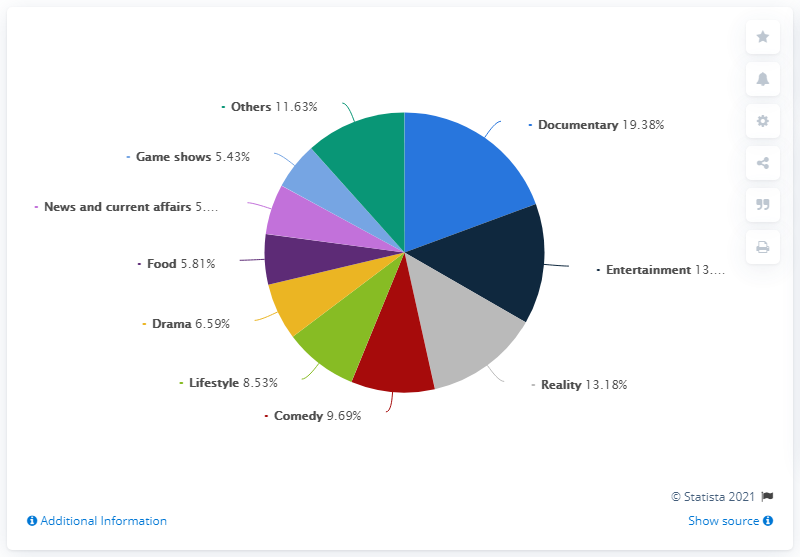How does the 'Entertainment' genre compare to the 'Reality' genre in terms of percentage? The 'Entertainment' genre makes up 13.47% of the chart, which is slightly more than the 'Reality' genre at 13.18%. 